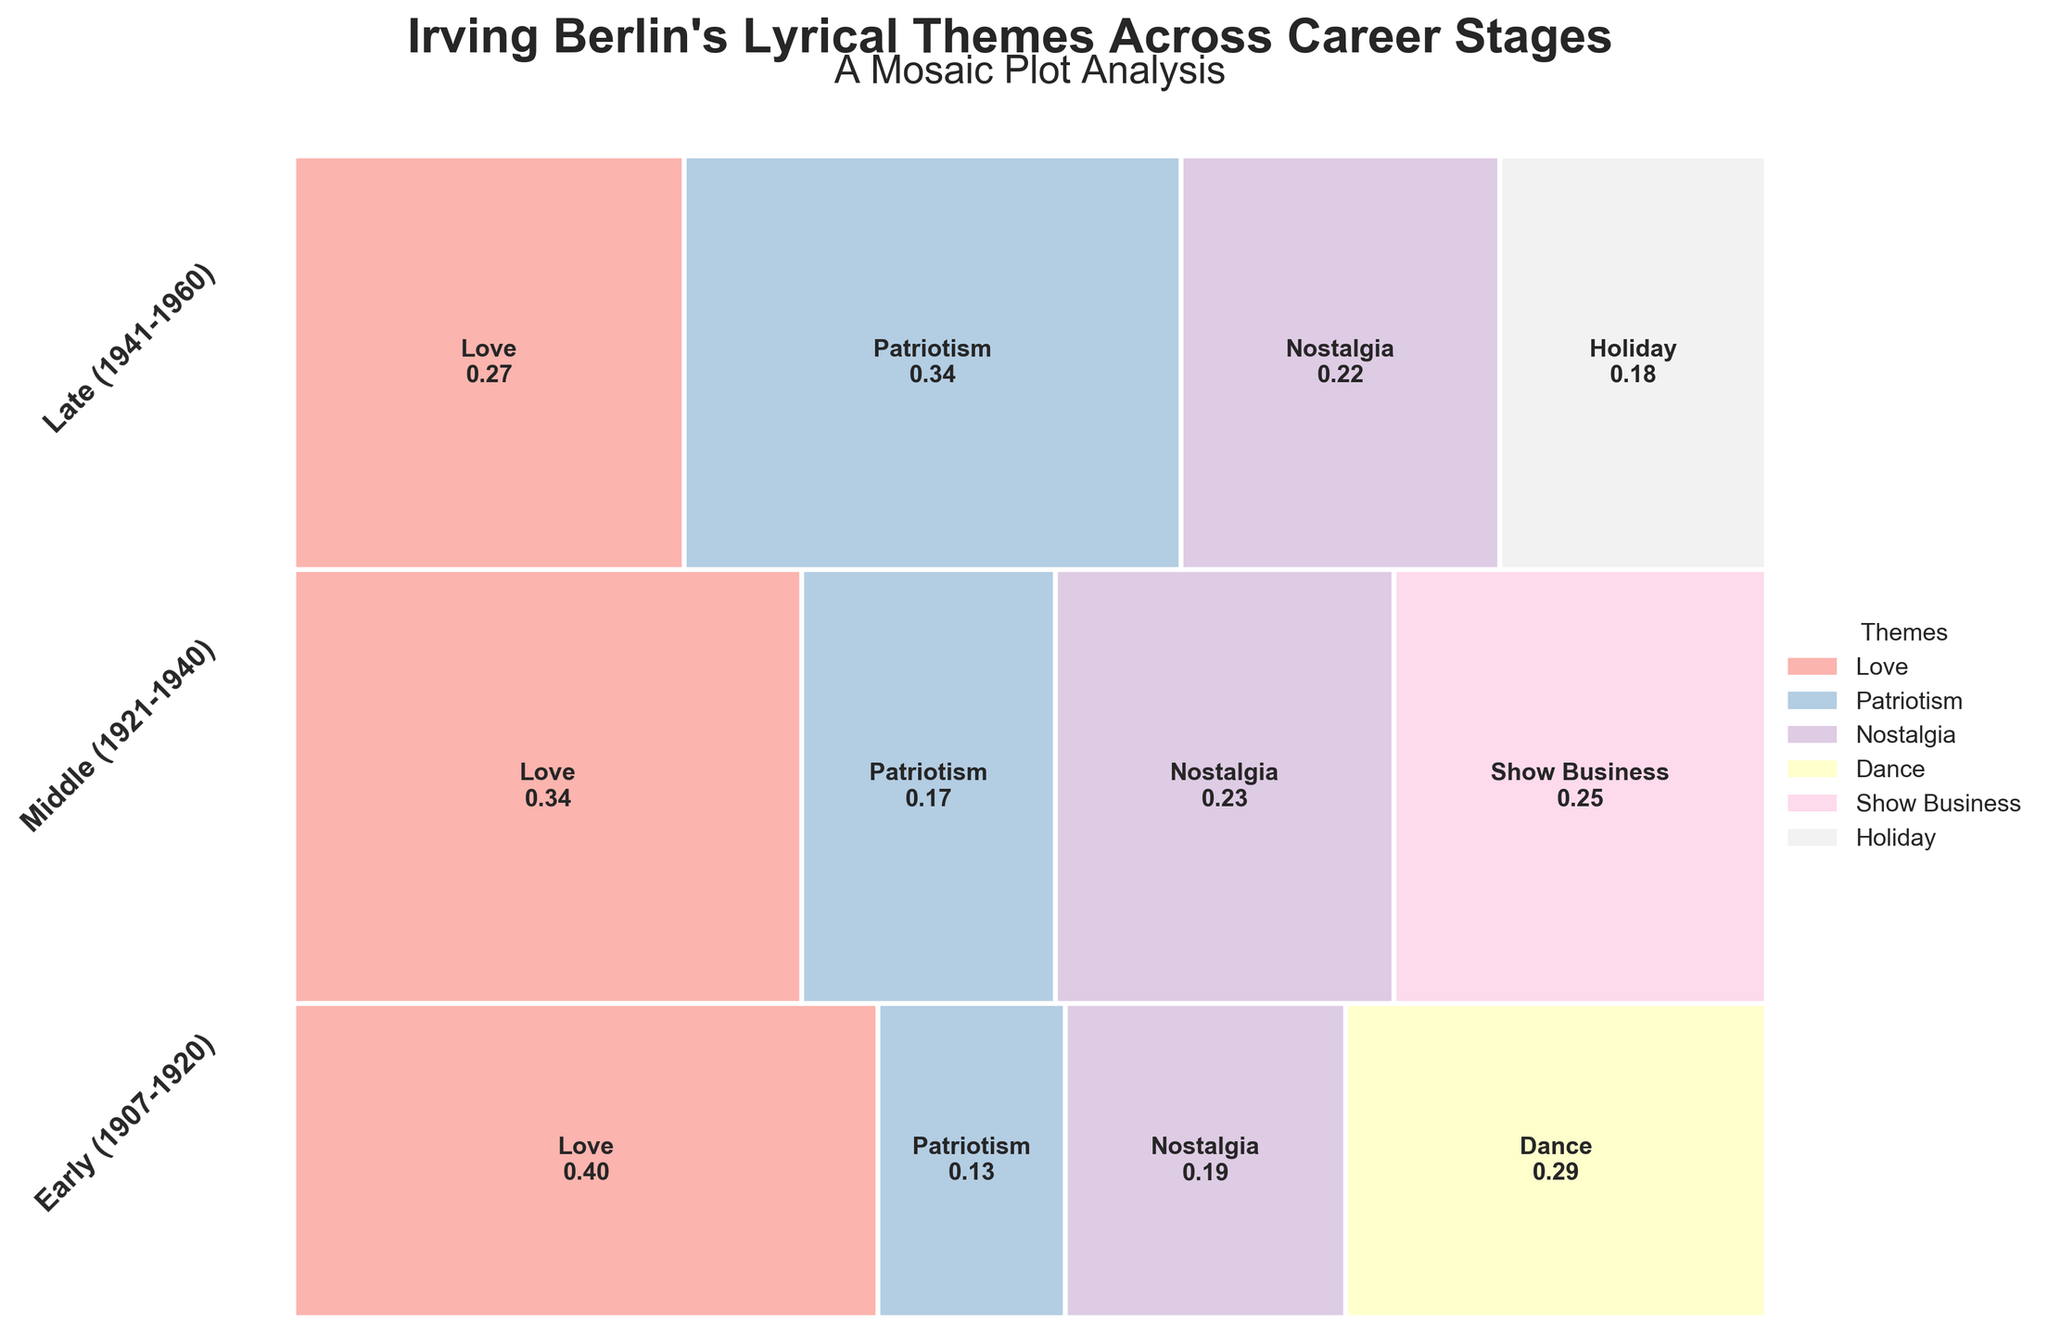Who wrote the song 'God Bless America'? The title of the plot is "Irving Berlin's Lyrical Themes Across Career Stages," indicating that the themes analyzed are from songs written by Irving Berlin. Thus, 'God Bless America' was written by him.
Answer: Irving Berlin Which career stage has the most songs about Patriotism? The Late career stage (1941-1960) contains the widest rectangle for Patriotism, indicating the highest count of songs in this theme compared to other stages.
Answer: Late (1941-1960) How many total songs does the Early career stage have? Sum of the counts for the Early career stage themes: Love (25) + Patriotism (8) + Nostalgia (12) + Dance (18).
Answer: 63 What proportion of Middle career stage songs are about Show Business? In the Middle career stage, the rectangle corresponding to Show Business is annotated with its proportion, which is the width of the rectangle. This width is approximately 0.19 or 19%.
Answer: 0.19 Which theme becomes more prominent in the Late career stage compared to the Early stage? Comparing the widths of the rectangles, Patriotism is much wider in the Late stage than in the Early stage, indicating an increase in prominence.
Answer: Patriotism Which two themes roughly have similar proportions in the Early career stage? In the Early career stage, the themes Dance and Nostalgia have similar widths, suggesting similar proportions.
Answer: Dance and Nostalgia What is the total proportion of songs about Love across all career stages? Calculate the proportion of Love in each stage and sum them: Early ~0.397, Middle ~0.326, Late ~0.237. Total = 0.397 + 0.326 + 0.237.
Answer: 0.96 Was Holiday a significant lyrical theme in the Early career stage? The plot shows no rectangle for Holiday in the Early career stage, indicating that this theme wasn't present during this period.
Answer: No In which career stage is the variety of musical themes the greatest? Count the number of different themes present in each career stage: Early (4), Middle (4), Late (4). Since the numbers are the same, the variety is equal across all stages.
Answer: Equal How does the proportion of songs about Nostalgia change over the career stages? By analyzing the proportions shown in the rectangles: Early ~0.19, Middle ~0.22, Late ~0.19, we see a slight increase in the Middle stage but generally similar otherwise.
Answer: Remains relatively stable 